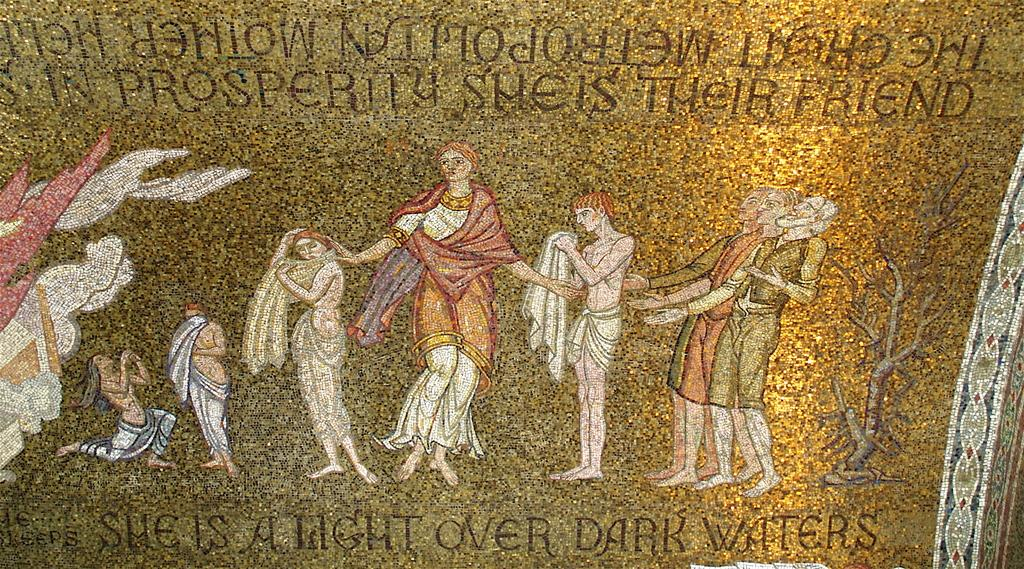What is the medium of the image? The image appears to be a painting on a wall. What can be seen in the image besides the painting? There are people standing in the image. What type of plant is depicted in the image? There is a tree with branches in the image. What else is featured in the image besides the people and the tree? There are letters visible in the image. Can you describe the intensity of the rainstorm in the image? There is no rainstorm present in the image; it features a painting with people, a tree, and letters. What type of clouds can be seen in the image? There are no clouds visible in the image, as it is a painting on a wall. 